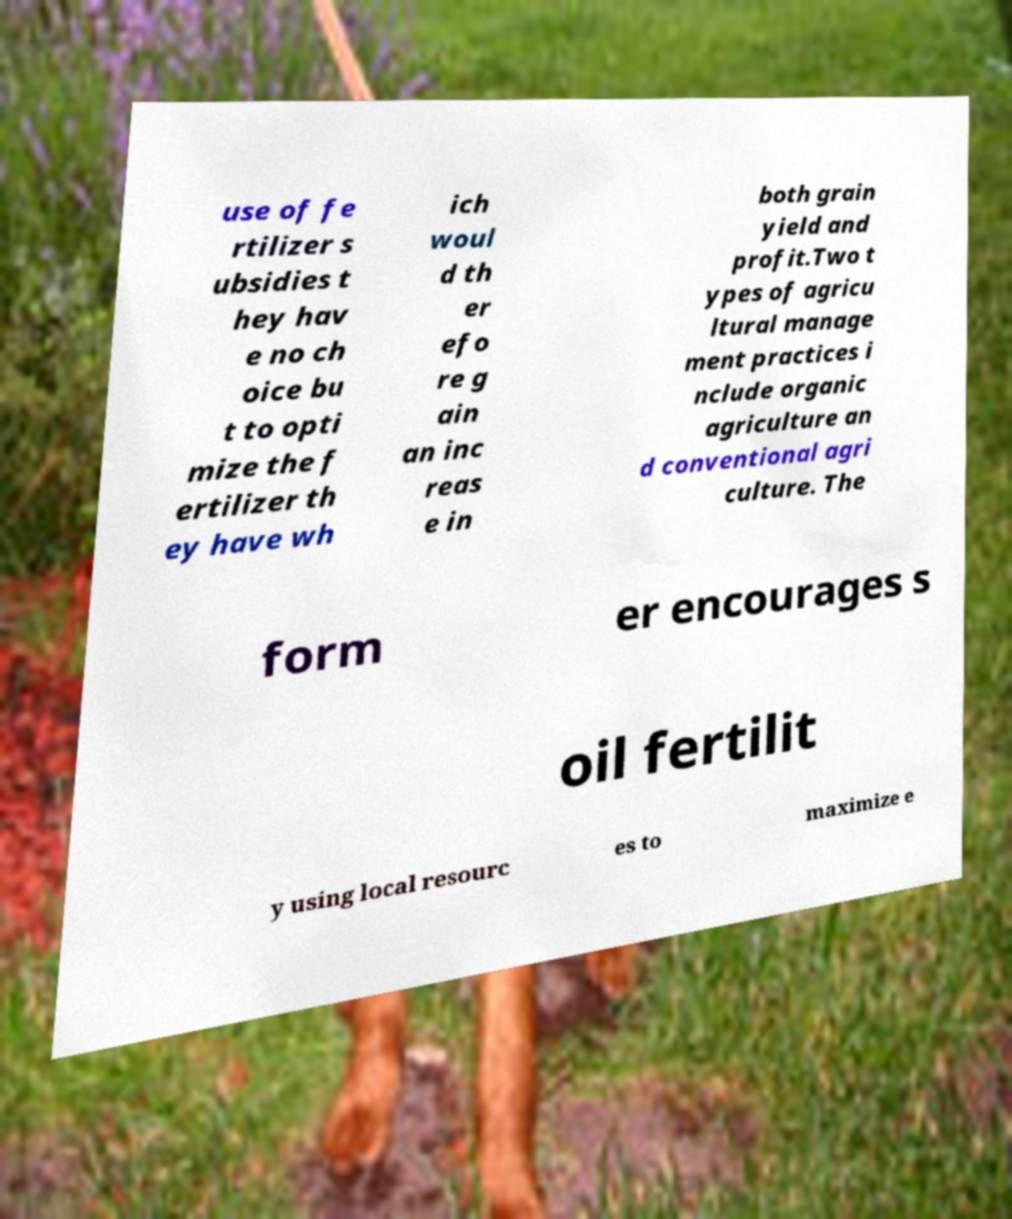For documentation purposes, I need the text within this image transcribed. Could you provide that? use of fe rtilizer s ubsidies t hey hav e no ch oice bu t to opti mize the f ertilizer th ey have wh ich woul d th er efo re g ain an inc reas e in both grain yield and profit.Two t ypes of agricu ltural manage ment practices i nclude organic agriculture an d conventional agri culture. The form er encourages s oil fertilit y using local resourc es to maximize e 